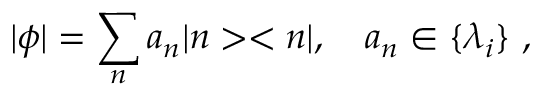<formula> <loc_0><loc_0><loc_500><loc_500>| \phi | = \sum _ { n } a _ { n } | n > < n | , \quad a _ { n } \in \{ \lambda _ { i } \} ,</formula> 